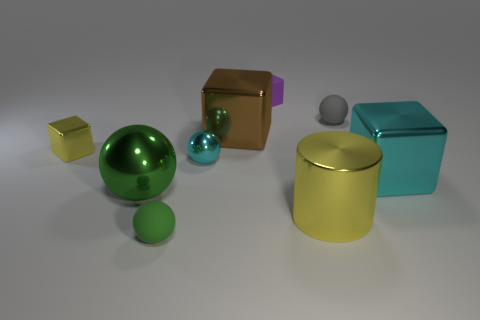There is a object that is the same color as the large sphere; what is its size?
Provide a short and direct response. Small. There is a shiny cube that is the same size as the gray thing; what color is it?
Offer a terse response. Yellow. What is the shape of the metallic object that is the same color as the shiny cylinder?
Ensure brevity in your answer.  Cube. There is a large object that is the same shape as the tiny cyan metal object; what is its color?
Offer a very short reply. Green. Are there any other things of the same color as the big cylinder?
Your response must be concise. Yes. There is a big cylinder; is its color the same as the small object right of the yellow cylinder?
Provide a succinct answer. No. There is a small rubber sphere on the left side of the metallic cylinder; is it the same color as the cylinder?
Offer a very short reply. No. What color is the large ball?
Make the answer very short. Green. There is a green object behind the tiny rubber sphere in front of the small yellow thing; what shape is it?
Provide a short and direct response. Sphere. Are there fewer tiny matte objects than small objects?
Offer a very short reply. Yes. 